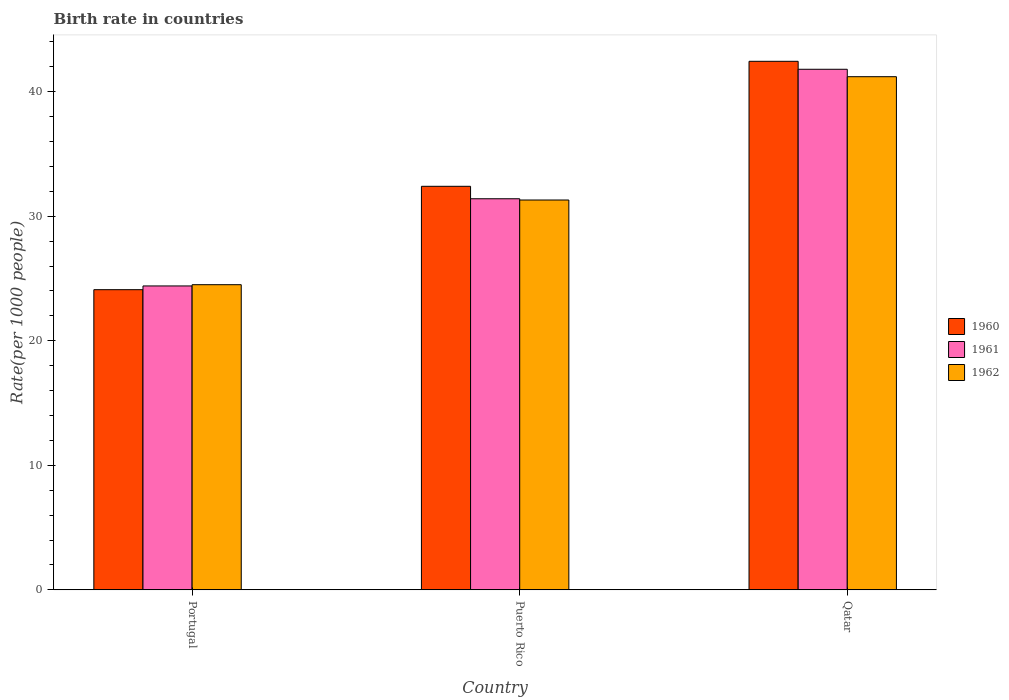How many different coloured bars are there?
Offer a terse response. 3. How many groups of bars are there?
Provide a short and direct response. 3. Are the number of bars per tick equal to the number of legend labels?
Keep it short and to the point. Yes. How many bars are there on the 3rd tick from the right?
Provide a succinct answer. 3. What is the label of the 3rd group of bars from the left?
Keep it short and to the point. Qatar. In how many cases, is the number of bars for a given country not equal to the number of legend labels?
Offer a terse response. 0. What is the birth rate in 1962 in Puerto Rico?
Your answer should be compact. 31.3. Across all countries, what is the maximum birth rate in 1961?
Provide a succinct answer. 41.8. Across all countries, what is the minimum birth rate in 1960?
Your answer should be very brief. 24.1. In which country was the birth rate in 1961 maximum?
Your answer should be compact. Qatar. In which country was the birth rate in 1960 minimum?
Give a very brief answer. Portugal. What is the total birth rate in 1960 in the graph?
Offer a terse response. 98.94. What is the difference between the birth rate in 1960 in Puerto Rico and that in Qatar?
Offer a very short reply. -10.04. What is the difference between the birth rate in 1961 in Portugal and the birth rate in 1962 in Puerto Rico?
Offer a very short reply. -6.9. What is the average birth rate in 1962 per country?
Offer a very short reply. 32.33. What is the difference between the birth rate of/in 1962 and birth rate of/in 1960 in Qatar?
Your answer should be compact. -1.24. What is the ratio of the birth rate in 1961 in Puerto Rico to that in Qatar?
Your answer should be very brief. 0.75. What is the difference between the highest and the second highest birth rate in 1962?
Your answer should be very brief. -16.7. What is the difference between the highest and the lowest birth rate in 1960?
Provide a short and direct response. 18.34. In how many countries, is the birth rate in 1960 greater than the average birth rate in 1960 taken over all countries?
Offer a terse response. 1. Is the sum of the birth rate in 1961 in Portugal and Qatar greater than the maximum birth rate in 1962 across all countries?
Offer a very short reply. Yes. What does the 2nd bar from the left in Portugal represents?
Offer a very short reply. 1961. Are all the bars in the graph horizontal?
Ensure brevity in your answer.  No. How many countries are there in the graph?
Offer a terse response. 3. What is the difference between two consecutive major ticks on the Y-axis?
Give a very brief answer. 10. Does the graph contain any zero values?
Ensure brevity in your answer.  No. Does the graph contain grids?
Make the answer very short. No. Where does the legend appear in the graph?
Provide a short and direct response. Center right. How many legend labels are there?
Keep it short and to the point. 3. What is the title of the graph?
Make the answer very short. Birth rate in countries. Does "1973" appear as one of the legend labels in the graph?
Provide a succinct answer. No. What is the label or title of the X-axis?
Offer a very short reply. Country. What is the label or title of the Y-axis?
Provide a short and direct response. Rate(per 1000 people). What is the Rate(per 1000 people) in 1960 in Portugal?
Offer a terse response. 24.1. What is the Rate(per 1000 people) in 1961 in Portugal?
Offer a terse response. 24.4. What is the Rate(per 1000 people) in 1962 in Portugal?
Your answer should be very brief. 24.5. What is the Rate(per 1000 people) in 1960 in Puerto Rico?
Make the answer very short. 32.4. What is the Rate(per 1000 people) of 1961 in Puerto Rico?
Keep it short and to the point. 31.4. What is the Rate(per 1000 people) in 1962 in Puerto Rico?
Your response must be concise. 31.3. What is the Rate(per 1000 people) of 1960 in Qatar?
Provide a short and direct response. 42.44. What is the Rate(per 1000 people) in 1961 in Qatar?
Your response must be concise. 41.8. What is the Rate(per 1000 people) of 1962 in Qatar?
Your answer should be very brief. 41.2. Across all countries, what is the maximum Rate(per 1000 people) in 1960?
Offer a terse response. 42.44. Across all countries, what is the maximum Rate(per 1000 people) of 1961?
Give a very brief answer. 41.8. Across all countries, what is the maximum Rate(per 1000 people) in 1962?
Offer a very short reply. 41.2. Across all countries, what is the minimum Rate(per 1000 people) of 1960?
Make the answer very short. 24.1. Across all countries, what is the minimum Rate(per 1000 people) of 1961?
Provide a short and direct response. 24.4. Across all countries, what is the minimum Rate(per 1000 people) of 1962?
Your answer should be very brief. 24.5. What is the total Rate(per 1000 people) of 1960 in the graph?
Provide a short and direct response. 98.94. What is the total Rate(per 1000 people) in 1961 in the graph?
Your answer should be compact. 97.6. What is the total Rate(per 1000 people) in 1962 in the graph?
Give a very brief answer. 97. What is the difference between the Rate(per 1000 people) of 1960 in Portugal and that in Qatar?
Keep it short and to the point. -18.34. What is the difference between the Rate(per 1000 people) in 1961 in Portugal and that in Qatar?
Your response must be concise. -17.4. What is the difference between the Rate(per 1000 people) of 1962 in Portugal and that in Qatar?
Ensure brevity in your answer.  -16.7. What is the difference between the Rate(per 1000 people) of 1960 in Puerto Rico and that in Qatar?
Keep it short and to the point. -10.04. What is the difference between the Rate(per 1000 people) in 1961 in Puerto Rico and that in Qatar?
Keep it short and to the point. -10.4. What is the difference between the Rate(per 1000 people) in 1962 in Puerto Rico and that in Qatar?
Keep it short and to the point. -9.9. What is the difference between the Rate(per 1000 people) in 1960 in Portugal and the Rate(per 1000 people) in 1961 in Puerto Rico?
Offer a terse response. -7.3. What is the difference between the Rate(per 1000 people) of 1960 in Portugal and the Rate(per 1000 people) of 1961 in Qatar?
Provide a short and direct response. -17.7. What is the difference between the Rate(per 1000 people) in 1960 in Portugal and the Rate(per 1000 people) in 1962 in Qatar?
Give a very brief answer. -17.1. What is the difference between the Rate(per 1000 people) of 1961 in Portugal and the Rate(per 1000 people) of 1962 in Qatar?
Ensure brevity in your answer.  -16.8. What is the difference between the Rate(per 1000 people) of 1960 in Puerto Rico and the Rate(per 1000 people) of 1961 in Qatar?
Make the answer very short. -9.4. What is the average Rate(per 1000 people) of 1960 per country?
Your answer should be compact. 32.98. What is the average Rate(per 1000 people) in 1961 per country?
Your response must be concise. 32.53. What is the average Rate(per 1000 people) of 1962 per country?
Ensure brevity in your answer.  32.33. What is the difference between the Rate(per 1000 people) in 1961 and Rate(per 1000 people) in 1962 in Portugal?
Offer a terse response. -0.1. What is the difference between the Rate(per 1000 people) in 1960 and Rate(per 1000 people) in 1962 in Puerto Rico?
Provide a short and direct response. 1.1. What is the difference between the Rate(per 1000 people) in 1961 and Rate(per 1000 people) in 1962 in Puerto Rico?
Provide a succinct answer. 0.1. What is the difference between the Rate(per 1000 people) in 1960 and Rate(per 1000 people) in 1961 in Qatar?
Make the answer very short. 0.64. What is the difference between the Rate(per 1000 people) in 1960 and Rate(per 1000 people) in 1962 in Qatar?
Give a very brief answer. 1.24. What is the difference between the Rate(per 1000 people) of 1961 and Rate(per 1000 people) of 1962 in Qatar?
Offer a terse response. 0.6. What is the ratio of the Rate(per 1000 people) of 1960 in Portugal to that in Puerto Rico?
Your answer should be compact. 0.74. What is the ratio of the Rate(per 1000 people) of 1961 in Portugal to that in Puerto Rico?
Your answer should be very brief. 0.78. What is the ratio of the Rate(per 1000 people) of 1962 in Portugal to that in Puerto Rico?
Your response must be concise. 0.78. What is the ratio of the Rate(per 1000 people) in 1960 in Portugal to that in Qatar?
Offer a terse response. 0.57. What is the ratio of the Rate(per 1000 people) of 1961 in Portugal to that in Qatar?
Offer a terse response. 0.58. What is the ratio of the Rate(per 1000 people) in 1962 in Portugal to that in Qatar?
Provide a short and direct response. 0.59. What is the ratio of the Rate(per 1000 people) in 1960 in Puerto Rico to that in Qatar?
Offer a terse response. 0.76. What is the ratio of the Rate(per 1000 people) of 1961 in Puerto Rico to that in Qatar?
Your answer should be compact. 0.75. What is the ratio of the Rate(per 1000 people) of 1962 in Puerto Rico to that in Qatar?
Offer a terse response. 0.76. What is the difference between the highest and the second highest Rate(per 1000 people) of 1960?
Your answer should be very brief. 10.04. What is the difference between the highest and the second highest Rate(per 1000 people) in 1961?
Your answer should be very brief. 10.4. What is the difference between the highest and the lowest Rate(per 1000 people) of 1960?
Provide a short and direct response. 18.34. What is the difference between the highest and the lowest Rate(per 1000 people) of 1961?
Your answer should be compact. 17.4. 